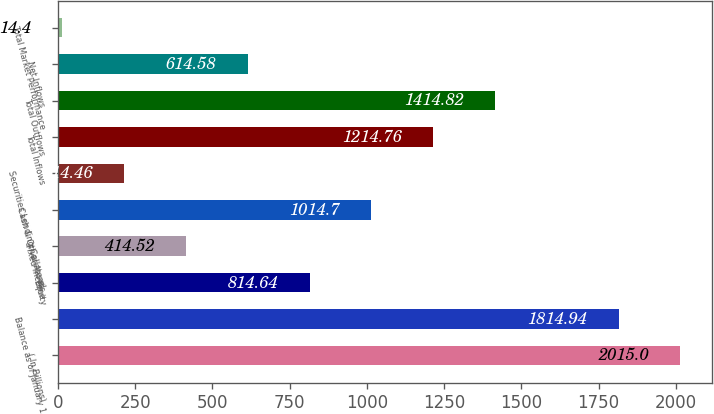Convert chart to OTSL. <chart><loc_0><loc_0><loc_500><loc_500><bar_chart><fcel>( In Billions)<fcel>Balance as of January 1<fcel>Equity<fcel>Fixed Income<fcel>Cash & Other Assets<fcel>Securities Lending Collateral<fcel>Total Inflows<fcel>Total Outflows<fcel>Net Inflows<fcel>Total Market Performance<nl><fcel>2015<fcel>1814.94<fcel>814.64<fcel>414.52<fcel>1014.7<fcel>214.46<fcel>1214.76<fcel>1414.82<fcel>614.58<fcel>14.4<nl></chart> 